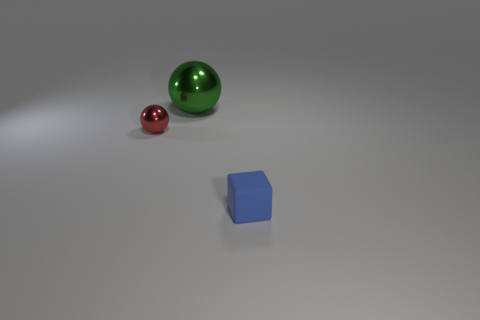Is there anything else that is made of the same material as the tiny blue thing?
Offer a very short reply. No. Is there anything else that is the same size as the green shiny ball?
Your answer should be very brief. No. Are the tiny thing to the left of the small blue object and the large green sphere made of the same material?
Offer a very short reply. Yes. Is the number of tiny red spheres right of the large green object the same as the number of red objects behind the tiny blue thing?
Your answer should be compact. No. There is a metallic object behind the small red shiny sphere; what size is it?
Make the answer very short. Large. Are there any tiny balls made of the same material as the big green object?
Ensure brevity in your answer.  Yes. Are there the same number of tiny shiny objects to the left of the cube and red spheres?
Provide a short and direct response. Yes. Are there any small matte blocks of the same color as the tiny metal ball?
Offer a terse response. No. Do the blue thing and the red metal ball have the same size?
Give a very brief answer. Yes. There is a object behind the small object on the left side of the tiny blue thing; how big is it?
Provide a succinct answer. Large. 